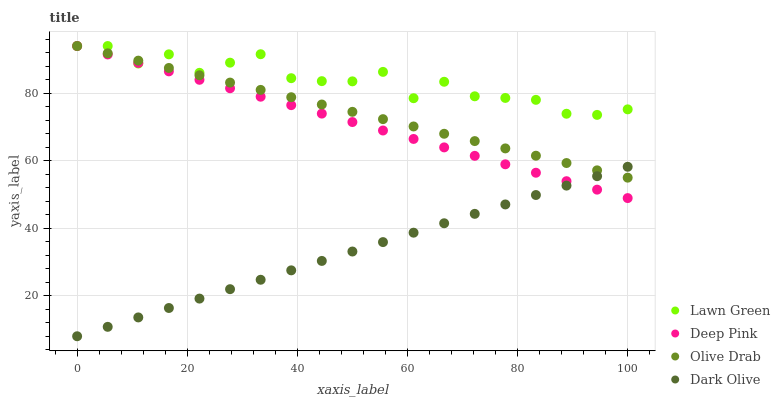Does Dark Olive have the minimum area under the curve?
Answer yes or no. Yes. Does Lawn Green have the maximum area under the curve?
Answer yes or no. Yes. Does Deep Pink have the minimum area under the curve?
Answer yes or no. No. Does Deep Pink have the maximum area under the curve?
Answer yes or no. No. Is Dark Olive the smoothest?
Answer yes or no. Yes. Is Lawn Green the roughest?
Answer yes or no. Yes. Is Deep Pink the smoothest?
Answer yes or no. No. Is Deep Pink the roughest?
Answer yes or no. No. Does Dark Olive have the lowest value?
Answer yes or no. Yes. Does Deep Pink have the lowest value?
Answer yes or no. No. Does Olive Drab have the highest value?
Answer yes or no. Yes. Is Dark Olive less than Lawn Green?
Answer yes or no. Yes. Is Lawn Green greater than Dark Olive?
Answer yes or no. Yes. Does Olive Drab intersect Dark Olive?
Answer yes or no. Yes. Is Olive Drab less than Dark Olive?
Answer yes or no. No. Is Olive Drab greater than Dark Olive?
Answer yes or no. No. Does Dark Olive intersect Lawn Green?
Answer yes or no. No. 